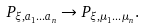Convert formula to latex. <formula><loc_0><loc_0><loc_500><loc_500>P _ { \xi , a _ { 1 } \dots a _ { n } } \rightarrow P _ { \xi , \mu _ { 1 } \dots \mu _ { n } } .</formula> 